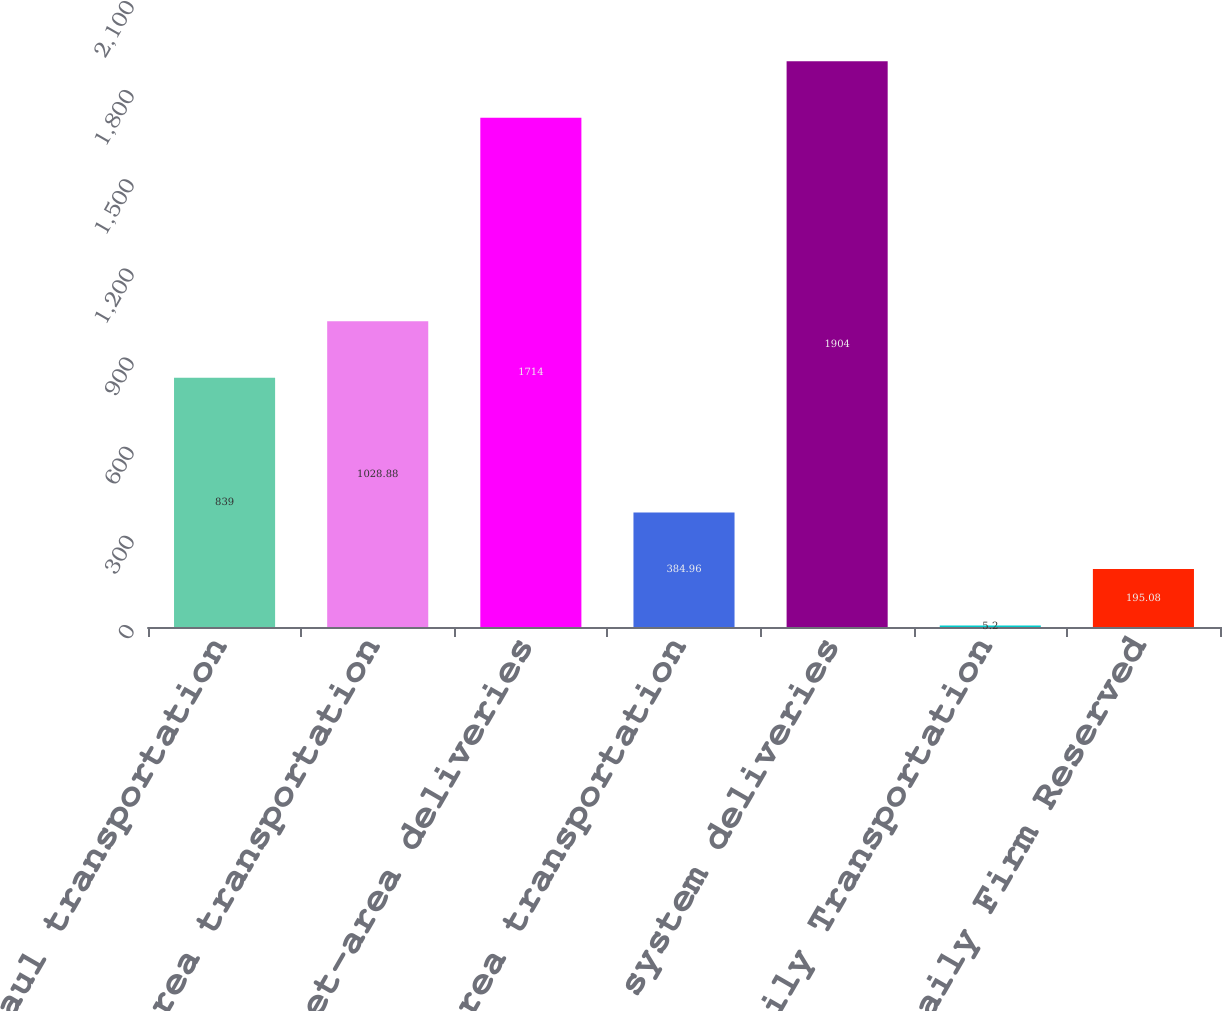Convert chart. <chart><loc_0><loc_0><loc_500><loc_500><bar_chart><fcel>Long-haul transportation<fcel>Market-area transportation<fcel>Total market-area deliveries<fcel>Production-area transportation<fcel>Total system deliveries<fcel>Average Daily Transportation<fcel>Average Daily Firm Reserved<nl><fcel>839<fcel>1028.88<fcel>1714<fcel>384.96<fcel>1904<fcel>5.2<fcel>195.08<nl></chart> 